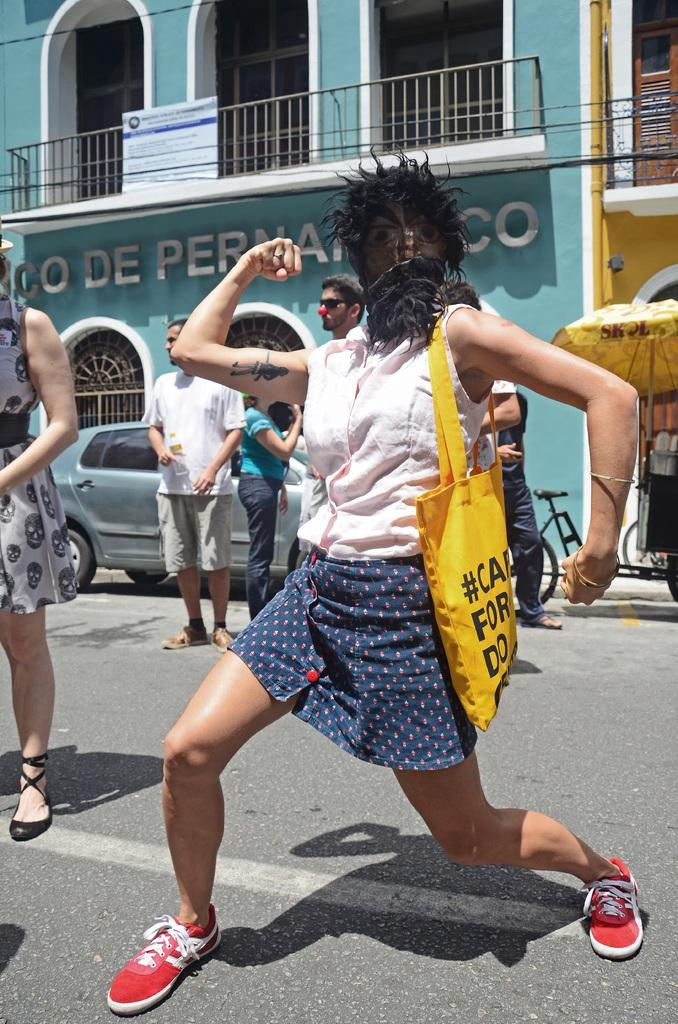Who is the main subject in the foreground of the image? There is a girl in the foreground of the image. What is happening around the girl? There are people around the girl. What can be seen in the background of the image? There is a building in the background of the image. What is in front of the building? There is a car in front of the building. What type of camp can be seen in the image? There is no camp present in the image; it features a girl, people, a building, and a car. 